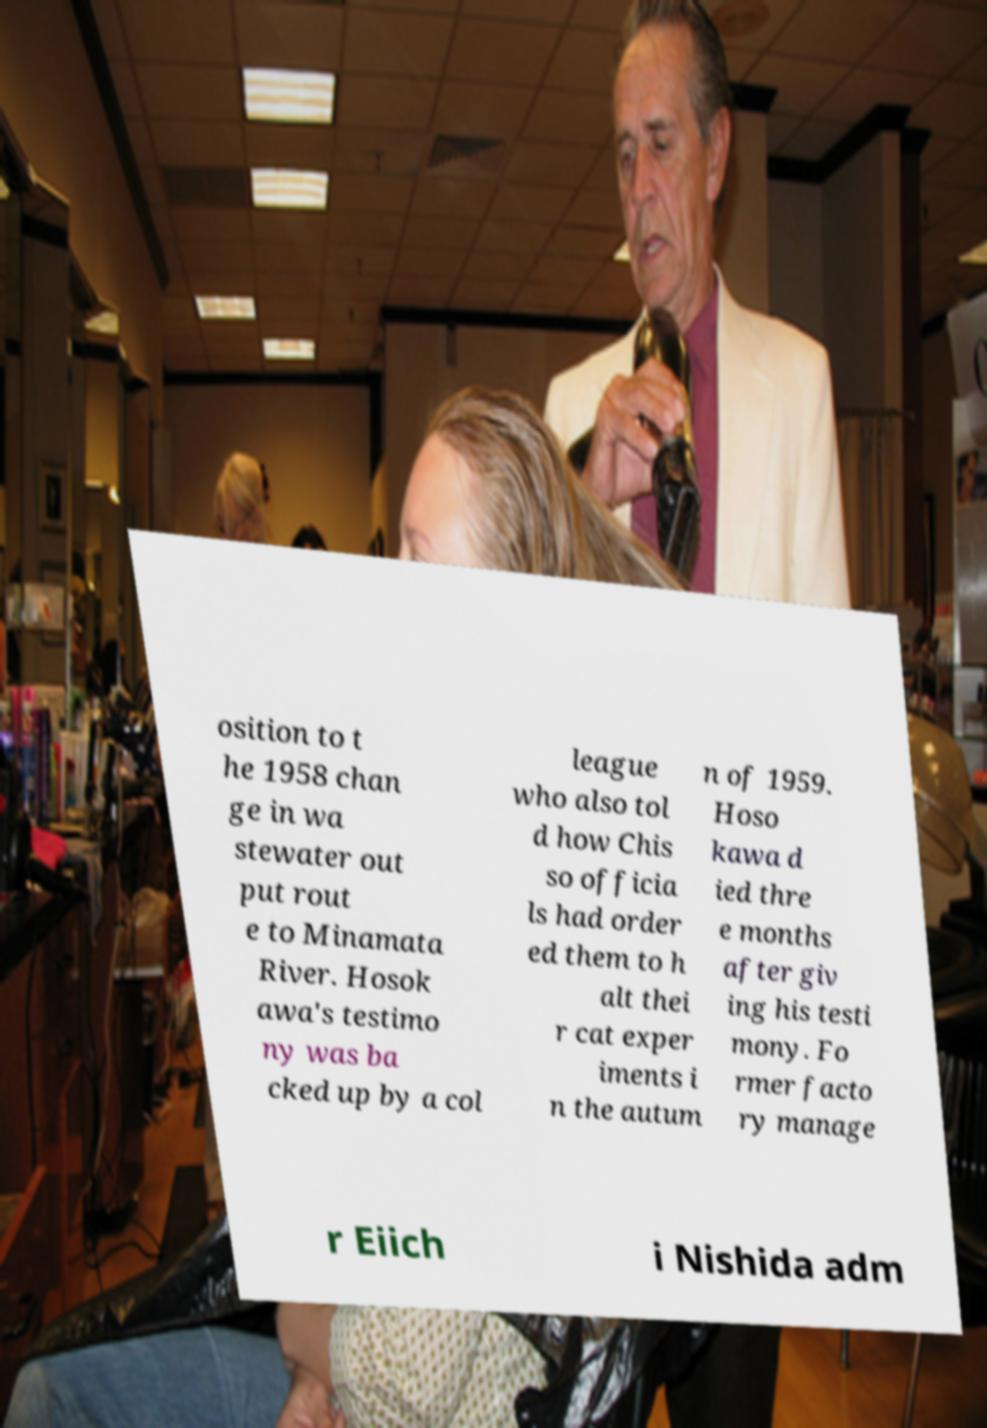For documentation purposes, I need the text within this image transcribed. Could you provide that? osition to t he 1958 chan ge in wa stewater out put rout e to Minamata River. Hosok awa's testimo ny was ba cked up by a col league who also tol d how Chis so officia ls had order ed them to h alt thei r cat exper iments i n the autum n of 1959. Hoso kawa d ied thre e months after giv ing his testi mony. Fo rmer facto ry manage r Eiich i Nishida adm 